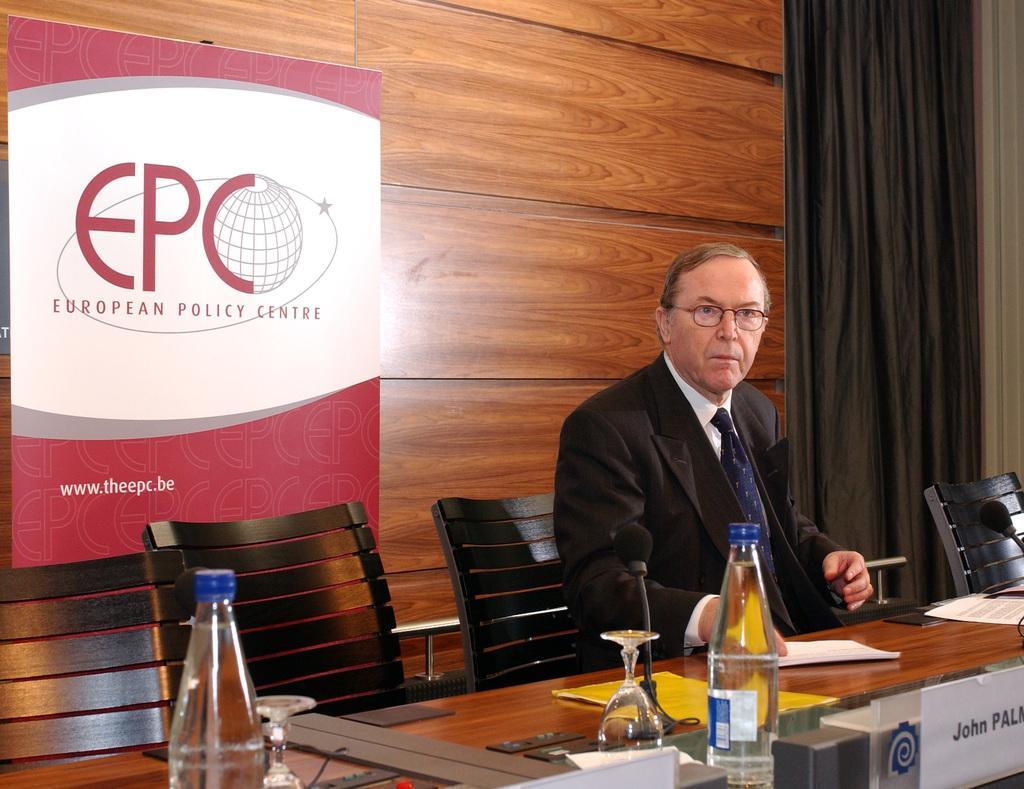In one or two sentences, can you explain what this image depicts? In the image we can see there is a person who is sitting on chair and the chairs are in black colour, on the table there is water bottle, wine glass, papers, mic with a stand and name plate and behind there is a banner. 